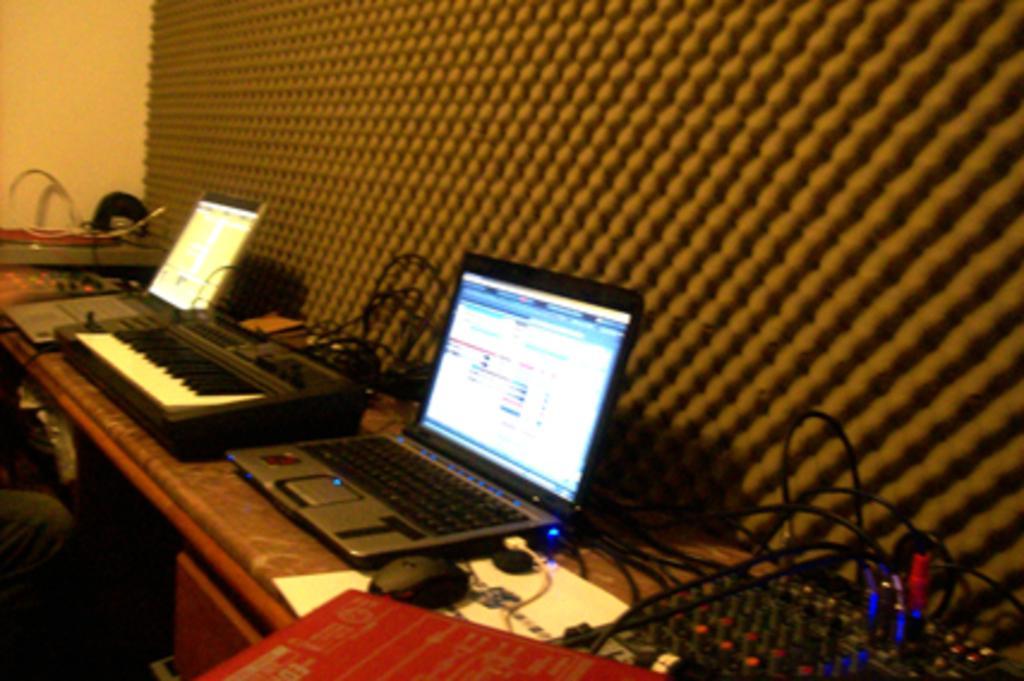In one or two sentences, can you explain what this image depicts? In this picture there is a table at the right side of the image on which there are laptops and there is a piano in between the laptops, there is a person who is sitting at the left side of the image and there is a desk below the table at the left side of the image. 